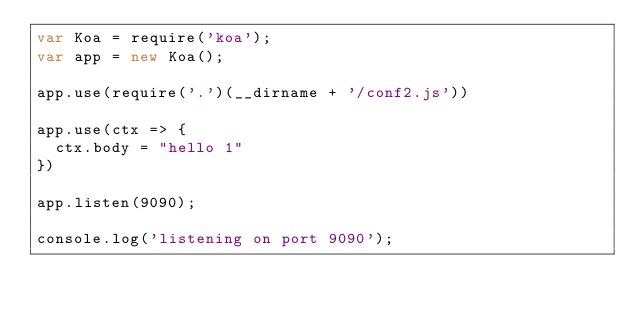Convert code to text. <code><loc_0><loc_0><loc_500><loc_500><_JavaScript_>var Koa = require('koa');
var app = new Koa();

app.use(require('.')(__dirname + '/conf2.js'))

app.use(ctx => {
  ctx.body = "hello 1"
})

app.listen(9090);

console.log('listening on port 9090');</code> 